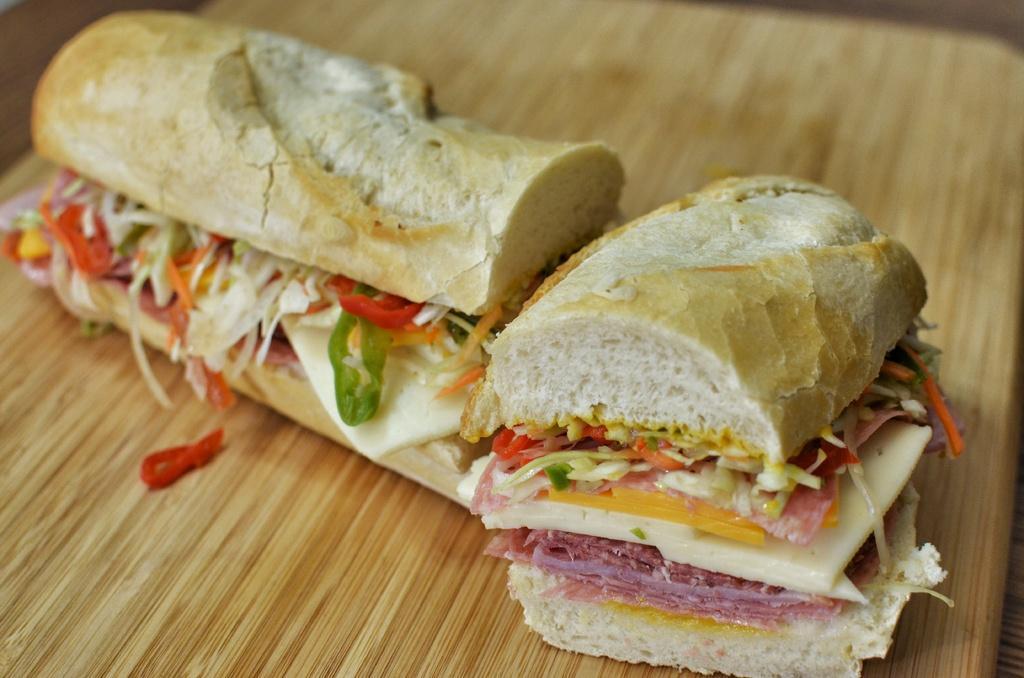Describe this image in one or two sentences. In this image there are two slices of burger on the wooden board. 